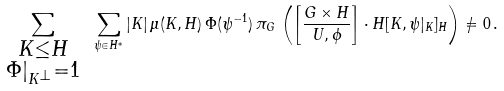<formula> <loc_0><loc_0><loc_500><loc_500>\sum _ { \substack { K \leq H \\ \Phi | _ { K ^ { \perp } } = 1 } } \ \sum _ { \psi \in H ^ { * } } | K | \, \mu ( K , H ) \, \Phi ( \psi ^ { - 1 } ) \, \pi _ { G } \, \left ( \left [ \frac { G \times H } { U , \phi } \right ] \cdot H [ K , \psi | _ { K } ] _ { H } \right ) \neq 0 \, .</formula> 